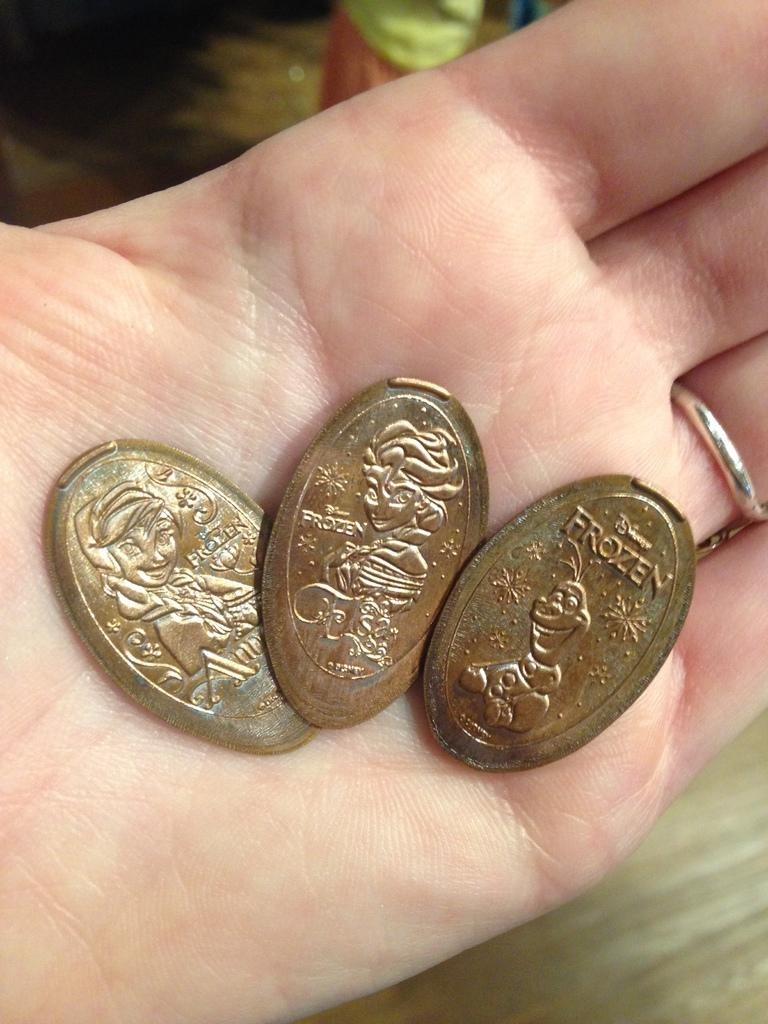<image>
Render a clear and concise summary of the photo. An opened hand with three flattened pennies and one says Frozen. 